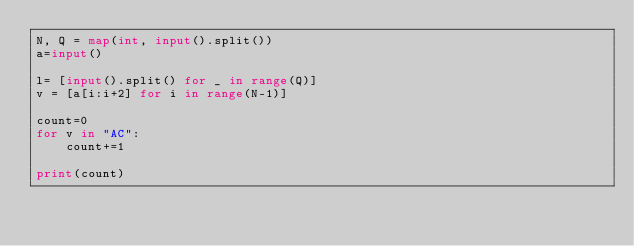Convert code to text. <code><loc_0><loc_0><loc_500><loc_500><_Python_>N, Q = map(int, input().split())
a=input()

l= [input().split() for _ in range(Q)]
v = [a[i:i+2] for i in range(N-1)]

count=0
for v in "AC":
    count+=1

print(count)</code> 